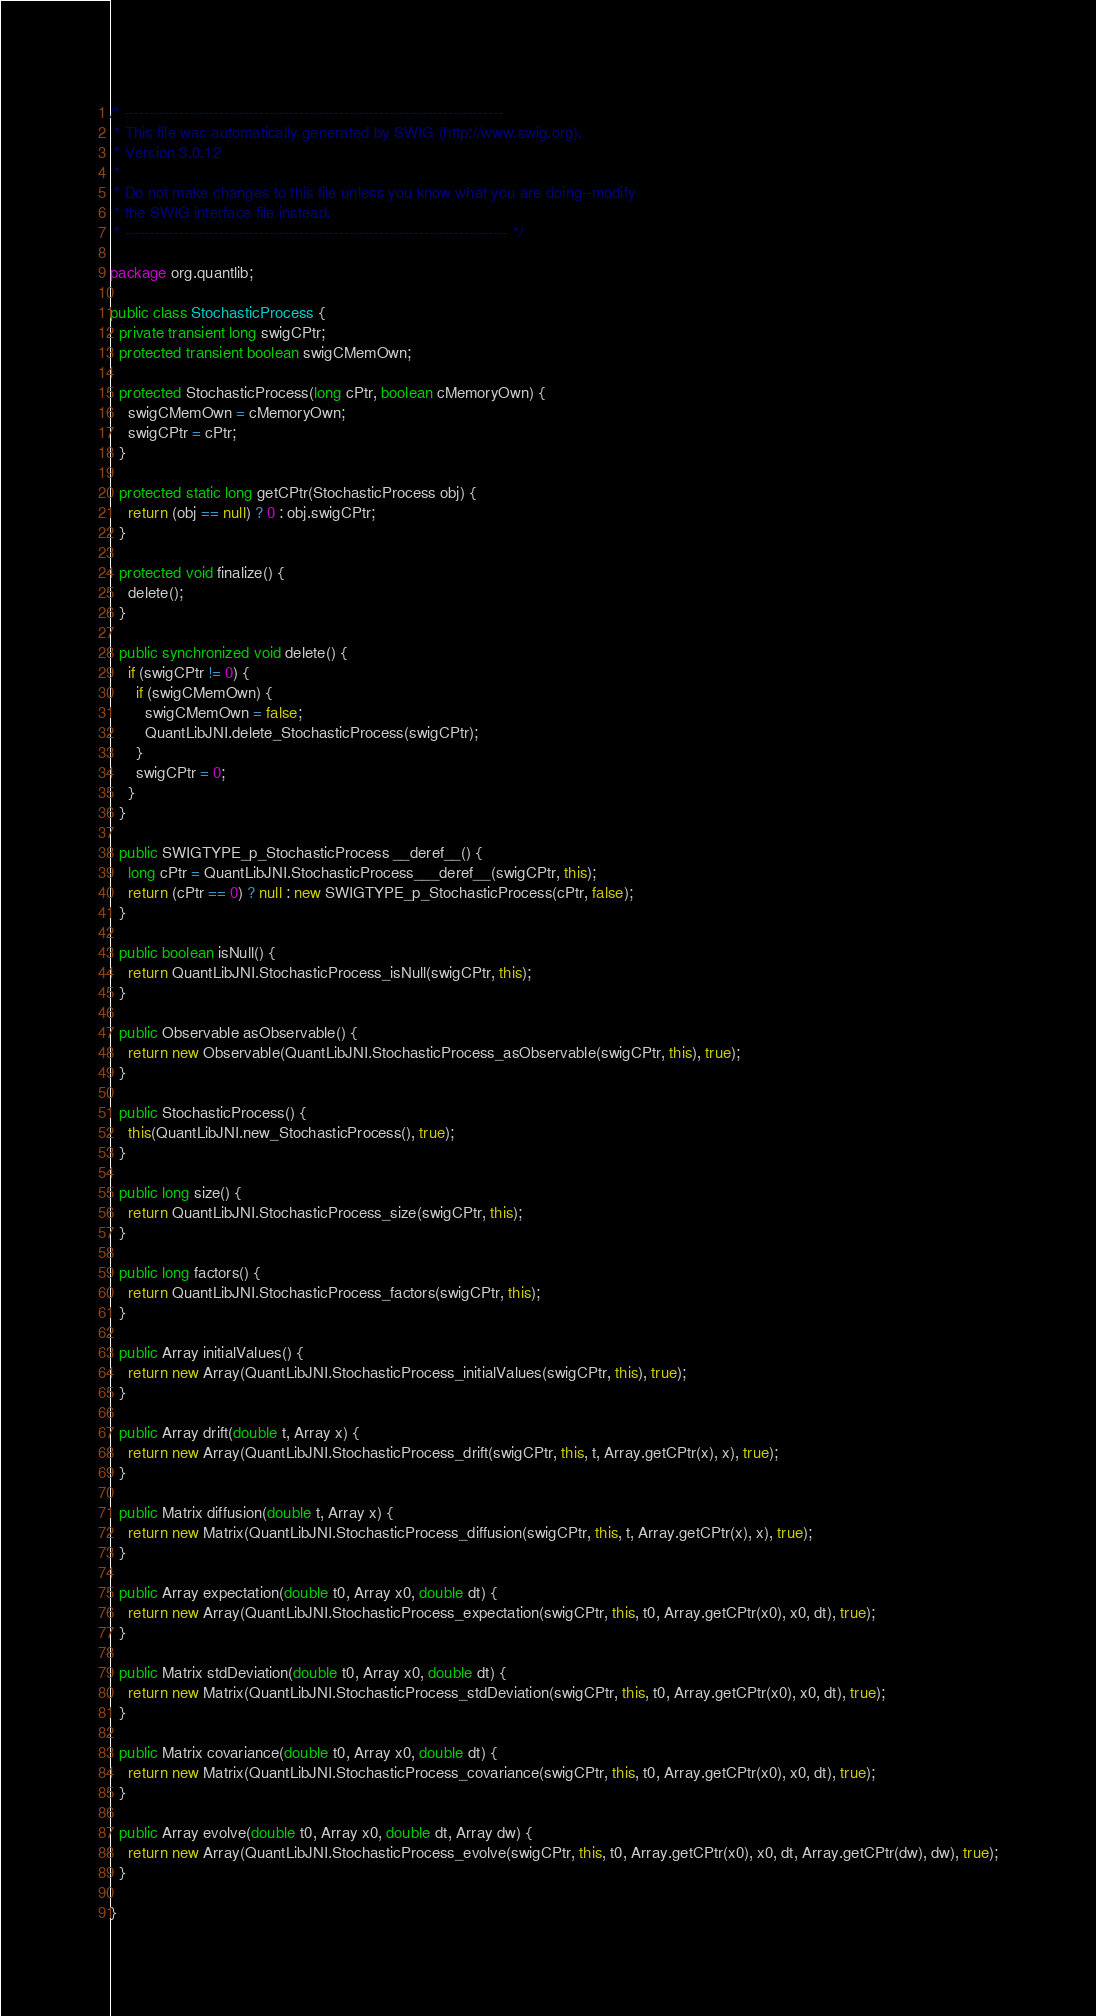Convert code to text. <code><loc_0><loc_0><loc_500><loc_500><_Java_>/* ----------------------------------------------------------------------------
 * This file was automatically generated by SWIG (http://www.swig.org).
 * Version 3.0.12
 *
 * Do not make changes to this file unless you know what you are doing--modify
 * the SWIG interface file instead.
 * ----------------------------------------------------------------------------- */

package org.quantlib;

public class StochasticProcess {
  private transient long swigCPtr;
  protected transient boolean swigCMemOwn;

  protected StochasticProcess(long cPtr, boolean cMemoryOwn) {
    swigCMemOwn = cMemoryOwn;
    swigCPtr = cPtr;
  }

  protected static long getCPtr(StochasticProcess obj) {
    return (obj == null) ? 0 : obj.swigCPtr;
  }

  protected void finalize() {
    delete();
  }

  public synchronized void delete() {
    if (swigCPtr != 0) {
      if (swigCMemOwn) {
        swigCMemOwn = false;
        QuantLibJNI.delete_StochasticProcess(swigCPtr);
      }
      swigCPtr = 0;
    }
  }

  public SWIGTYPE_p_StochasticProcess __deref__() {
    long cPtr = QuantLibJNI.StochasticProcess___deref__(swigCPtr, this);
    return (cPtr == 0) ? null : new SWIGTYPE_p_StochasticProcess(cPtr, false);
  }

  public boolean isNull() {
    return QuantLibJNI.StochasticProcess_isNull(swigCPtr, this);
  }

  public Observable asObservable() {
    return new Observable(QuantLibJNI.StochasticProcess_asObservable(swigCPtr, this), true);
  }

  public StochasticProcess() {
    this(QuantLibJNI.new_StochasticProcess(), true);
  }

  public long size() {
    return QuantLibJNI.StochasticProcess_size(swigCPtr, this);
  }

  public long factors() {
    return QuantLibJNI.StochasticProcess_factors(swigCPtr, this);
  }

  public Array initialValues() {
    return new Array(QuantLibJNI.StochasticProcess_initialValues(swigCPtr, this), true);
  }

  public Array drift(double t, Array x) {
    return new Array(QuantLibJNI.StochasticProcess_drift(swigCPtr, this, t, Array.getCPtr(x), x), true);
  }

  public Matrix diffusion(double t, Array x) {
    return new Matrix(QuantLibJNI.StochasticProcess_diffusion(swigCPtr, this, t, Array.getCPtr(x), x), true);
  }

  public Array expectation(double t0, Array x0, double dt) {
    return new Array(QuantLibJNI.StochasticProcess_expectation(swigCPtr, this, t0, Array.getCPtr(x0), x0, dt), true);
  }

  public Matrix stdDeviation(double t0, Array x0, double dt) {
    return new Matrix(QuantLibJNI.StochasticProcess_stdDeviation(swigCPtr, this, t0, Array.getCPtr(x0), x0, dt), true);
  }

  public Matrix covariance(double t0, Array x0, double dt) {
    return new Matrix(QuantLibJNI.StochasticProcess_covariance(swigCPtr, this, t0, Array.getCPtr(x0), x0, dt), true);
  }

  public Array evolve(double t0, Array x0, double dt, Array dw) {
    return new Array(QuantLibJNI.StochasticProcess_evolve(swigCPtr, this, t0, Array.getCPtr(x0), x0, dt, Array.getCPtr(dw), dw), true);
  }

}
</code> 